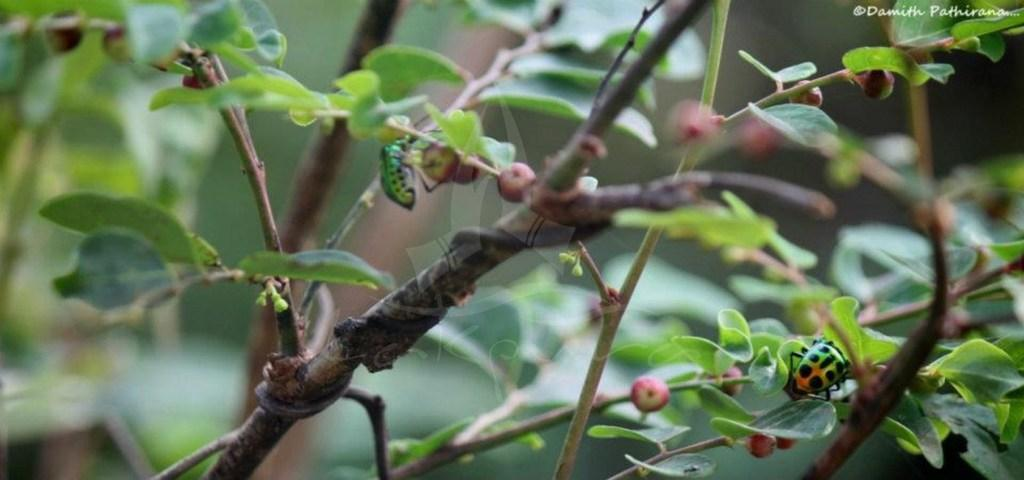What objects are present in the image? There are files, leaves, and fruits in the image. Where are the files located? The files are on branches of plants in the image. What type of vegetation can be seen in the image? There are leaves and fruits visible in the image. Where is the mailbox located in the image? There is no mailbox present in the image. What type of flower can be seen growing among the leaves in the image? There are no flowers visible in the image; only leaves and fruits are present. 